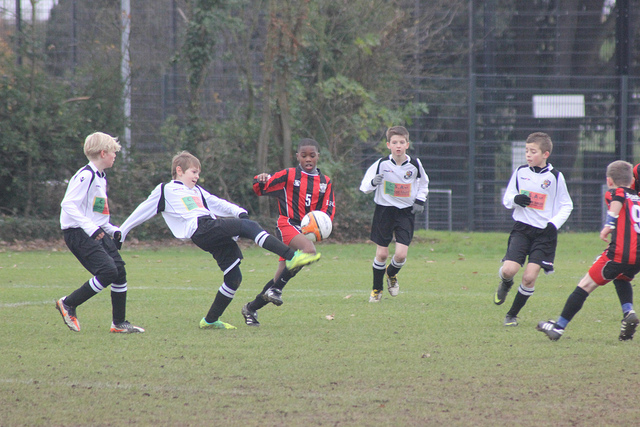Please extract the text content from this image. 5 